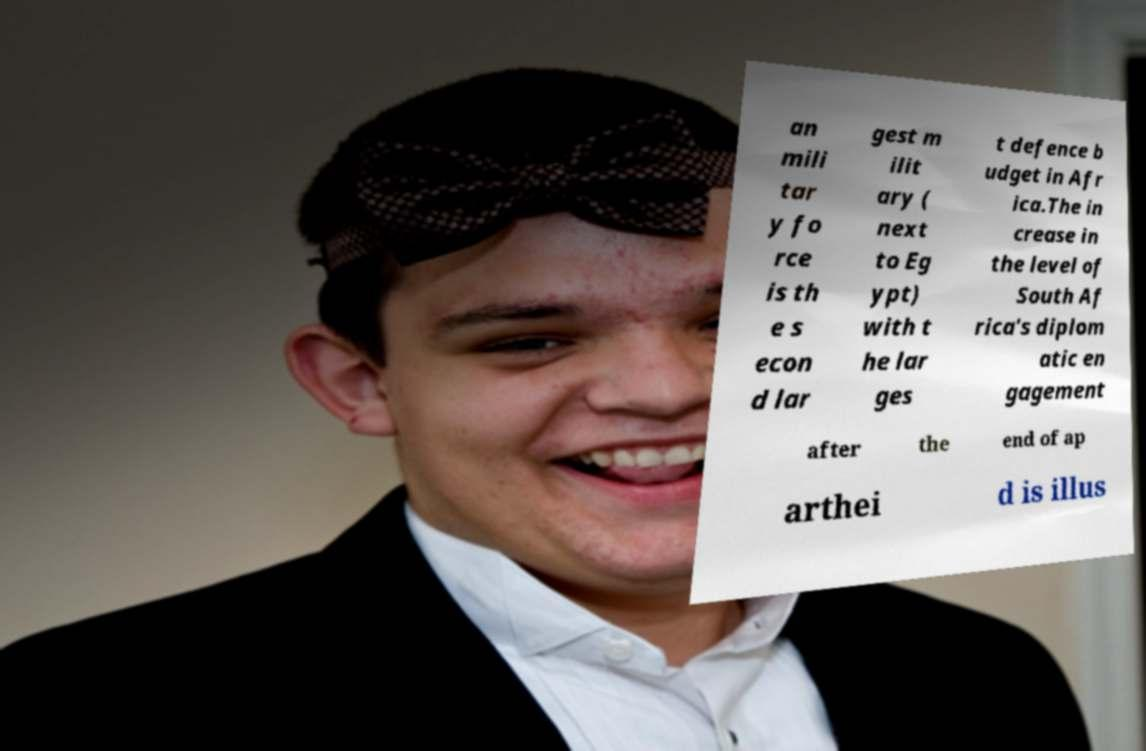Can you read and provide the text displayed in the image?This photo seems to have some interesting text. Can you extract and type it out for me? an mili tar y fo rce is th e s econ d lar gest m ilit ary ( next to Eg ypt) with t he lar ges t defence b udget in Afr ica.The in crease in the level of South Af rica's diplom atic en gagement after the end of ap arthei d is illus 